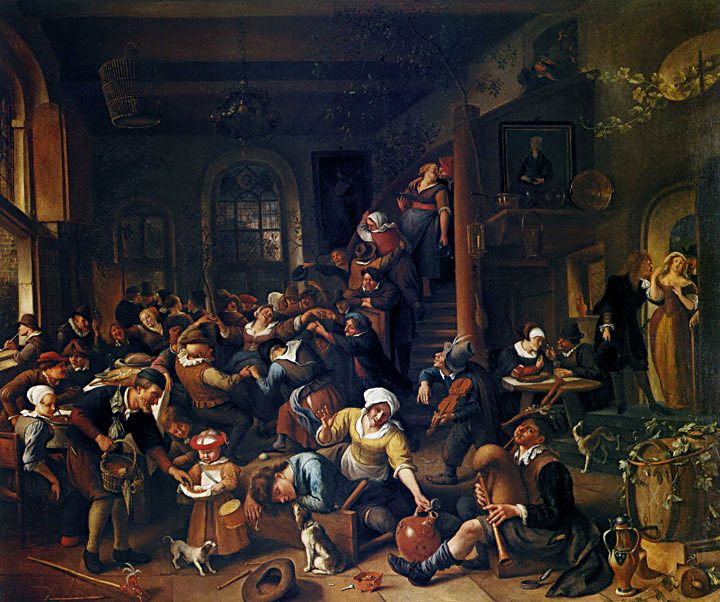What are the key elements in this picture? This image depicts a complex Baroque style oil painting featuring a bustling tavern scene filled with a diverse array of people engaged in various activities. The scene reveals a rich tapestry of human interaction, from eating and drinking to conversation and solitary contemplation. Key elements include the dynamic arrangement of figures, the dramatic interplay of light and dark that highlights certain characters and actions, and subtle details like the artwork on the walls and the intricate clothing of the figures. Furthermore, elements such as the scattered objects on the floor and the distant figure peeking from an upper door suggest narratives and add a layer of intrigue to the composition. This scene likely serves as a social commentary, reflecting the artist's views on society at the time. 